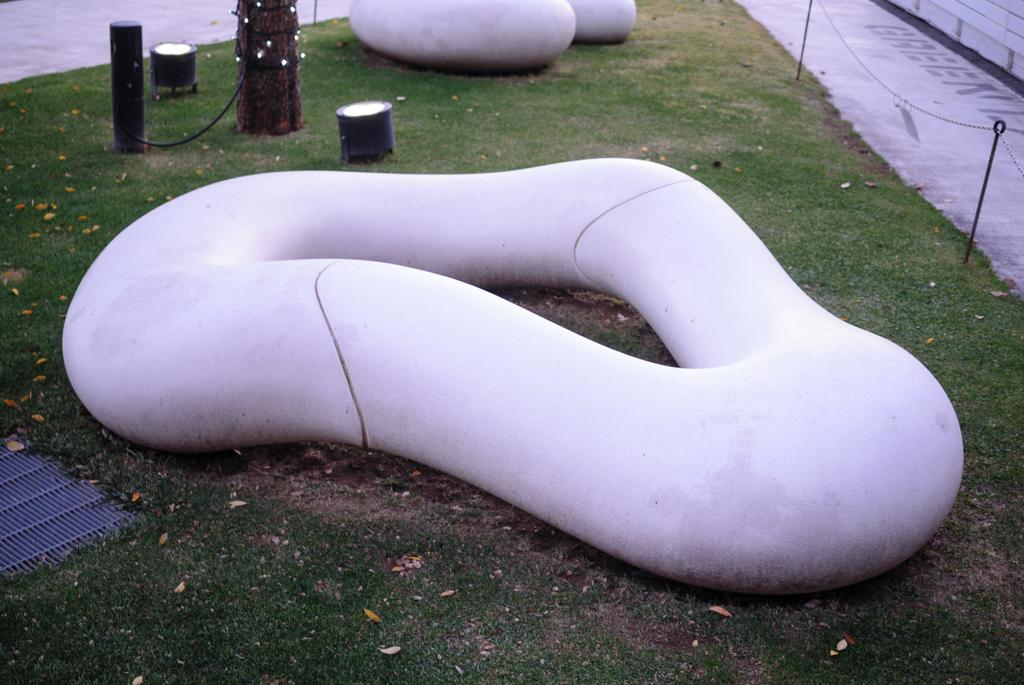What type of surface is visible in the image? There is ground visible in the image. What kind of vegetation is present on the ground? There is grass on the ground. What color are the objects in the image? There are objects in the image that are pink in color. What type of structures can be seen in the image? There are black colored poles in the image. What religious symbols can be seen in the image? There are no religious symbols present in the image. How many rings are visible on the black poles in the image? There are no rings visible on the black poles in the image. 